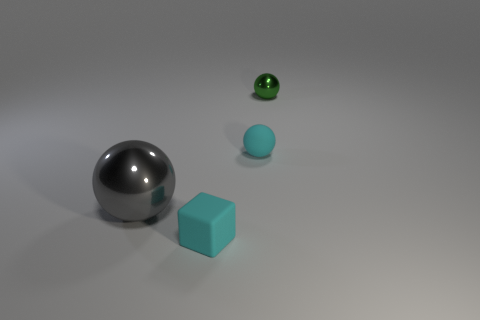Is there anything else that has the same size as the gray metallic object?
Keep it short and to the point. No. Is the number of things that are on the left side of the green metallic ball greater than the number of metallic things to the right of the large thing?
Keep it short and to the point. Yes. Are there any other things that have the same shape as the large gray object?
Provide a short and direct response. Yes. There is a metal ball right of the rubber cube; is it the same size as the big gray sphere?
Provide a short and direct response. No. Are any large red rubber cubes visible?
Keep it short and to the point. No. What number of things are either things in front of the green sphere or green metallic balls?
Provide a succinct answer. 4. There is a cube; does it have the same color as the small ball that is on the left side of the small shiny thing?
Keep it short and to the point. Yes. Are there any cyan cubes of the same size as the green metal object?
Provide a succinct answer. Yes. There is a tiny ball that is on the left side of the shiny ball behind the large shiny object; what is its material?
Your response must be concise. Rubber. How many matte balls have the same color as the block?
Provide a succinct answer. 1. 